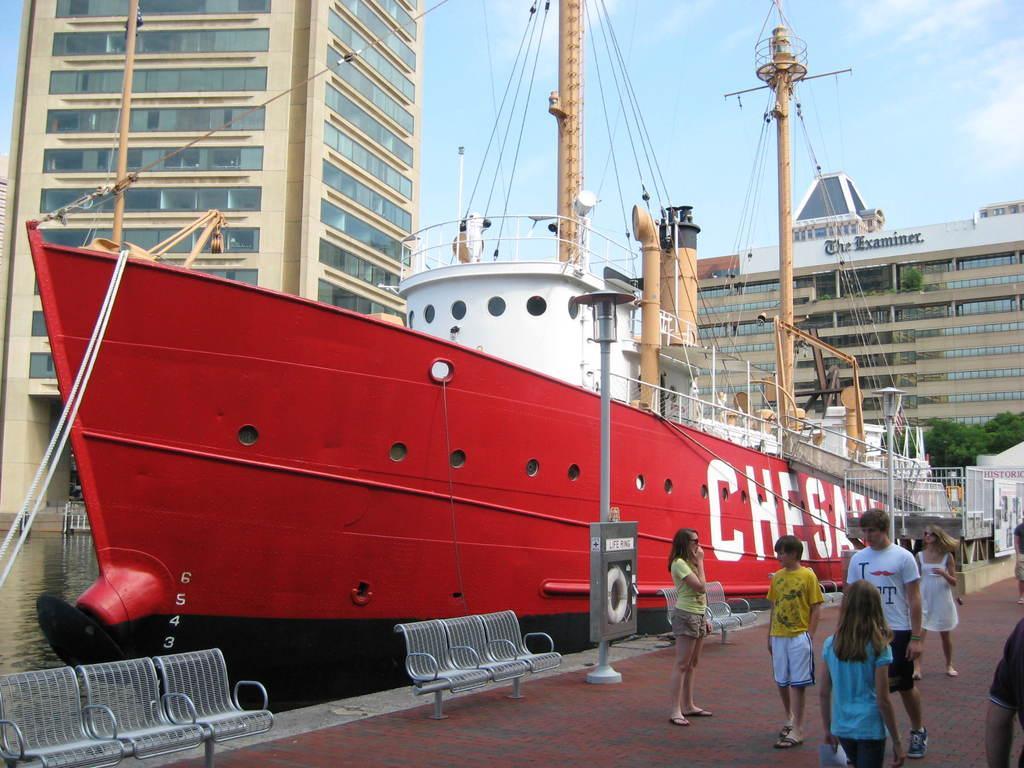Describe this image in one or two sentences. In this picture we can see a group of people standing on the walkway. On the left side of the people, there are benches, poles and there is a ship on the water. Behind the ship there are buildings and the sky. On the right side of the image, there are trees, iron grilles and a board. 